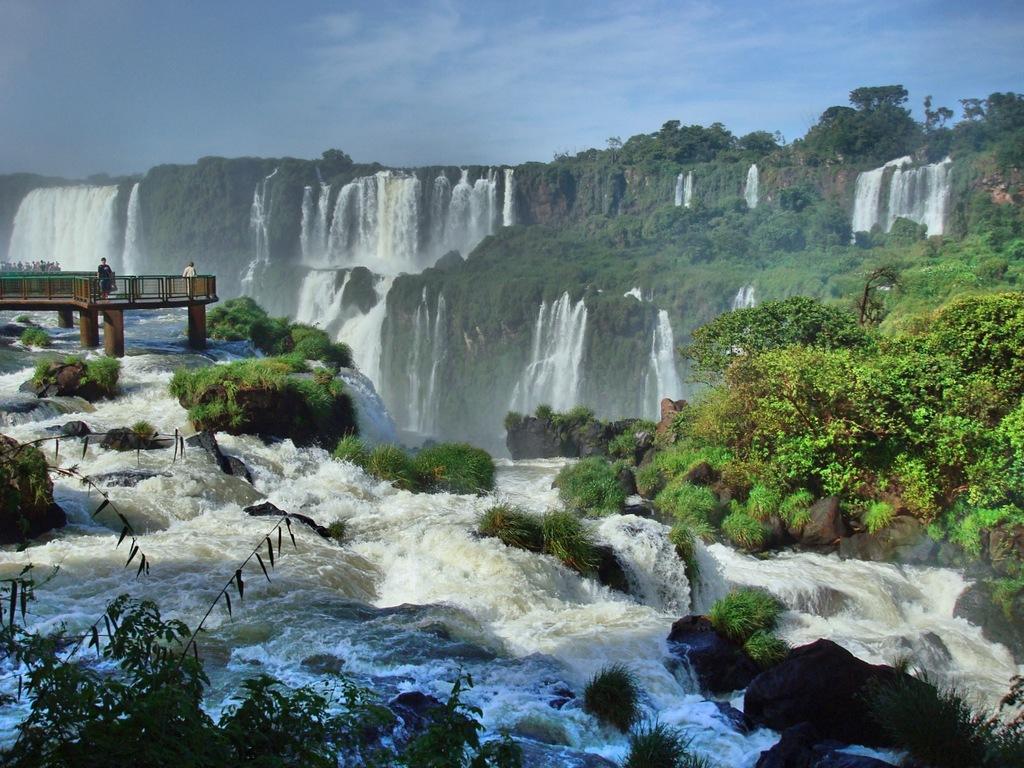Please provide a concise description of this image. In this image there are waterfalls, trees, in the middle there is a bridge on that bridge there are two persons standing. 